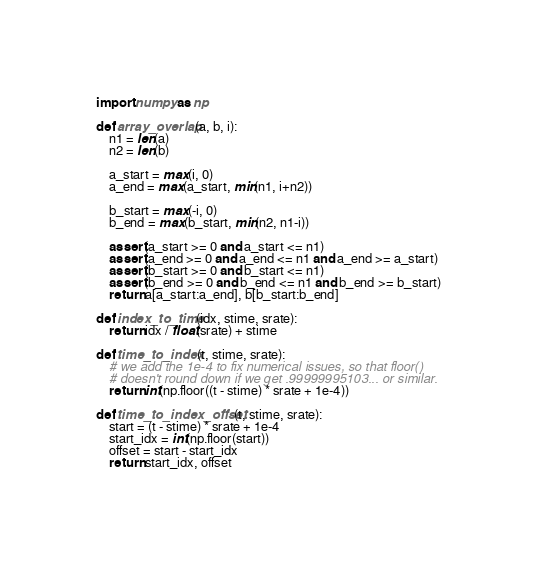Convert code to text. <code><loc_0><loc_0><loc_500><loc_500><_Python_>import numpy as np

def array_overlap(a, b, i):
    n1 = len(a)
    n2 = len(b)

    a_start = max(i, 0)
    a_end = max(a_start, min(n1, i+n2))

    b_start = max(-i, 0)
    b_end = max(b_start, min(n2, n1-i))

    assert(a_start >= 0 and a_start <= n1)
    assert(a_end >= 0 and a_end <= n1 and a_end >= a_start)
    assert(b_start >= 0 and b_start <= n1)
    assert(b_end >= 0 and b_end <= n1 and b_end >= b_start)
    return a[a_start:a_end], b[b_start:b_end]

def index_to_time(idx, stime, srate):
    return idx / float(srate) + stime

def time_to_index(t, stime, srate):
    # we add the 1e-4 to fix numerical issues, so that floor()
    # doesn't round down if we get .99999995103... or similar.
    return int(np.floor((t - stime) * srate + 1e-4))

def time_to_index_offset(t, stime, srate):
    start = (t - stime) * srate + 1e-4
    start_idx = int(np.floor(start))
    offset = start - start_idx
    return start_idx, offset
</code> 